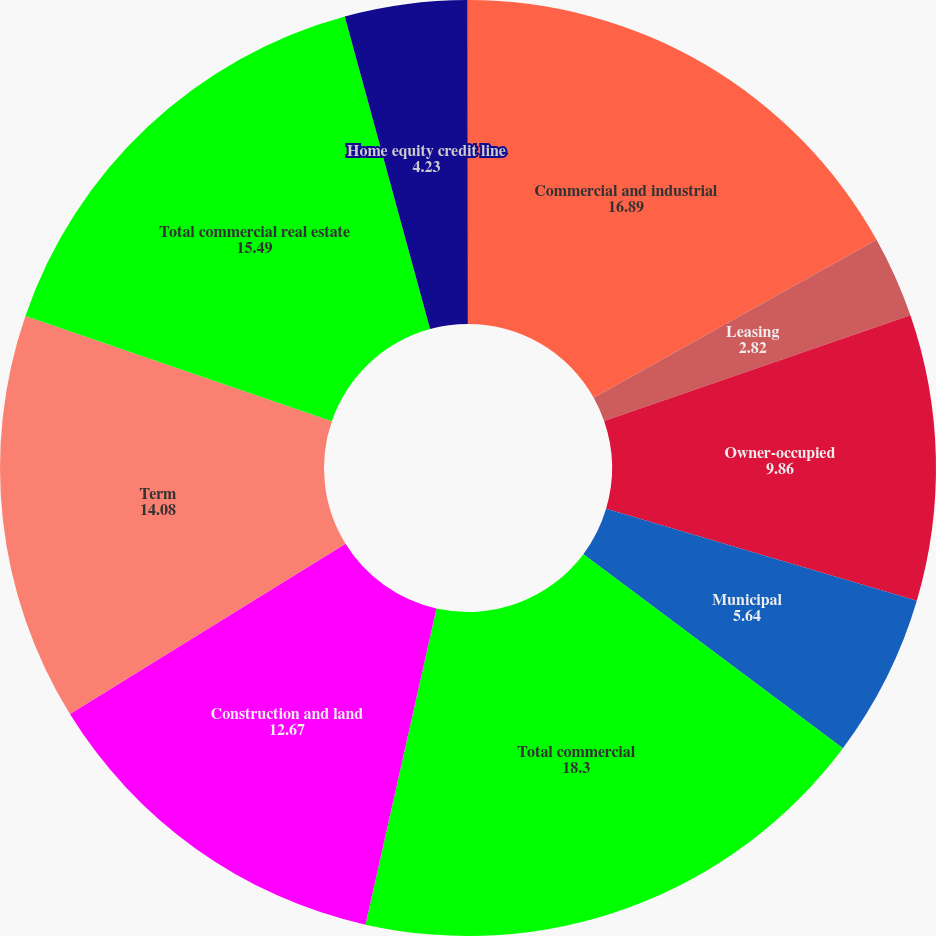Convert chart. <chart><loc_0><loc_0><loc_500><loc_500><pie_chart><fcel>Commercial and industrial<fcel>Leasing<fcel>Owner-occupied<fcel>Municipal<fcel>Total commercial<fcel>Construction and land<fcel>Term<fcel>Total commercial real estate<fcel>Home equity credit line<fcel>1-4 family residential<nl><fcel>16.89%<fcel>2.82%<fcel>9.86%<fcel>5.64%<fcel>18.3%<fcel>12.67%<fcel>14.08%<fcel>15.49%<fcel>4.23%<fcel>0.01%<nl></chart> 